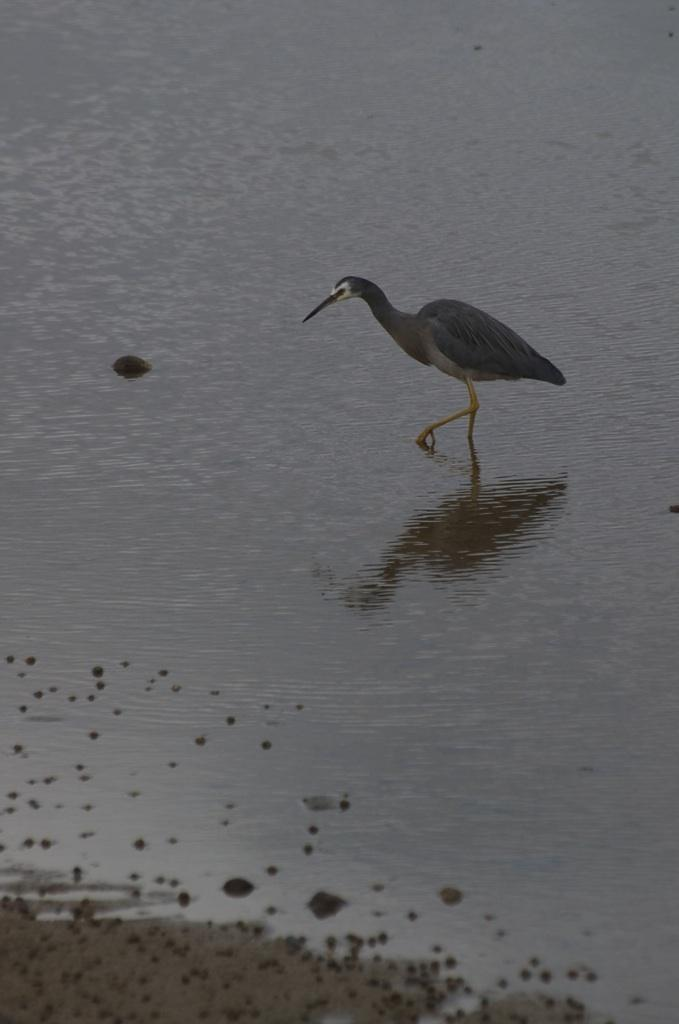What is on the water surface in the image? There is a bird on the water surface in the image. What can be seen at the bottom side of the image? There are stones at the bottom side of the image. What type of quiver is the bird holding in the image? There is no quiver present in the image; it features a bird on the water surface and stones at the bottom side. Can you describe the bone structure of the bird in the image? There is no information about the bird's bone structure provided in the image, as it only shows the bird on the water surface and stones at the bottom side. 